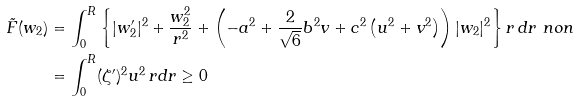<formula> <loc_0><loc_0><loc_500><loc_500>\tilde { F } ( w _ { 2 } ) & = \int _ { 0 } ^ { R } \left \{ | w ^ { \prime } _ { 2 } | ^ { 2 } + \frac { w _ { 2 } ^ { 2 } } { r ^ { 2 } } + \left ( - a ^ { 2 } + \frac { 2 } { \sqrt { 6 } } b ^ { 2 } v + c ^ { 2 } \left ( u ^ { 2 } + v ^ { 2 } \right ) \right ) | w _ { 2 } | ^ { 2 } \right \} r \, d r \ n o n \\ & = \int _ { 0 } ^ { R } ( \zeta ^ { \prime } ) ^ { 2 } u ^ { 2 } \, r d r \geq 0</formula> 